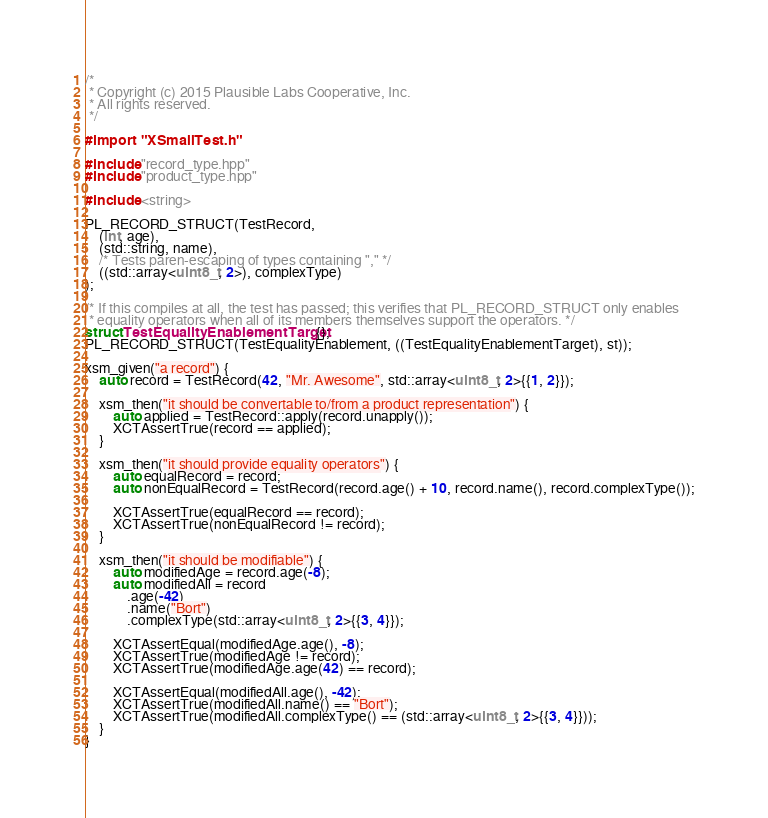Convert code to text. <code><loc_0><loc_0><loc_500><loc_500><_ObjectiveC_>/*
 * Copyright (c) 2015 Plausible Labs Cooperative, Inc.
 * All rights reserved.
 */

#import "XSmallTest.h"

#include "record_type.hpp"
#include "product_type.hpp"

#include <string>

PL_RECORD_STRUCT(TestRecord,
    (int, age),
    (std::string, name),
    /* Tests paren-escaping of types containing "," */
    ((std::array<uint8_t, 2>), complexType)
);

/* If this compiles at all, the test has passed; this verifies that PL_RECORD_STRUCT only enables
 * equality operators when all of its members themselves support the operators. */
struct TestEqualityEnablementTarget {};
PL_RECORD_STRUCT(TestEqualityEnablement, ((TestEqualityEnablementTarget), st));

xsm_given("a record") {
    auto record = TestRecord(42, "Mr. Awesome", std::array<uint8_t, 2>{{1, 2}});
    
    xsm_then("it should be convertable to/from a product representation") {
        auto applied = TestRecord::apply(record.unapply());
        XCTAssertTrue(record == applied);
    }
    
    xsm_then("it should provide equality operators") {
        auto equalRecord = record;
        auto nonEqualRecord = TestRecord(record.age() + 10, record.name(), record.complexType());
        
        XCTAssertTrue(equalRecord == record);
        XCTAssertTrue(nonEqualRecord != record);
    }
    
    xsm_then("it should be modifiable") {
        auto modifiedAge = record.age(-8);
        auto modifiedAll = record
            .age(-42)
            .name("Bort")
            .complexType(std::array<uint8_t, 2>{{3, 4}});
        
        XCTAssertEqual(modifiedAge.age(), -8);
        XCTAssertTrue(modifiedAge != record);
        XCTAssertTrue(modifiedAge.age(42) == record);
        
        XCTAssertEqual(modifiedAll.age(), -42);
        XCTAssertTrue(modifiedAll.name() == "Bort");
        XCTAssertTrue(modifiedAll.complexType() == (std::array<uint8_t, 2>{{3, 4}}));
    }
}</code> 